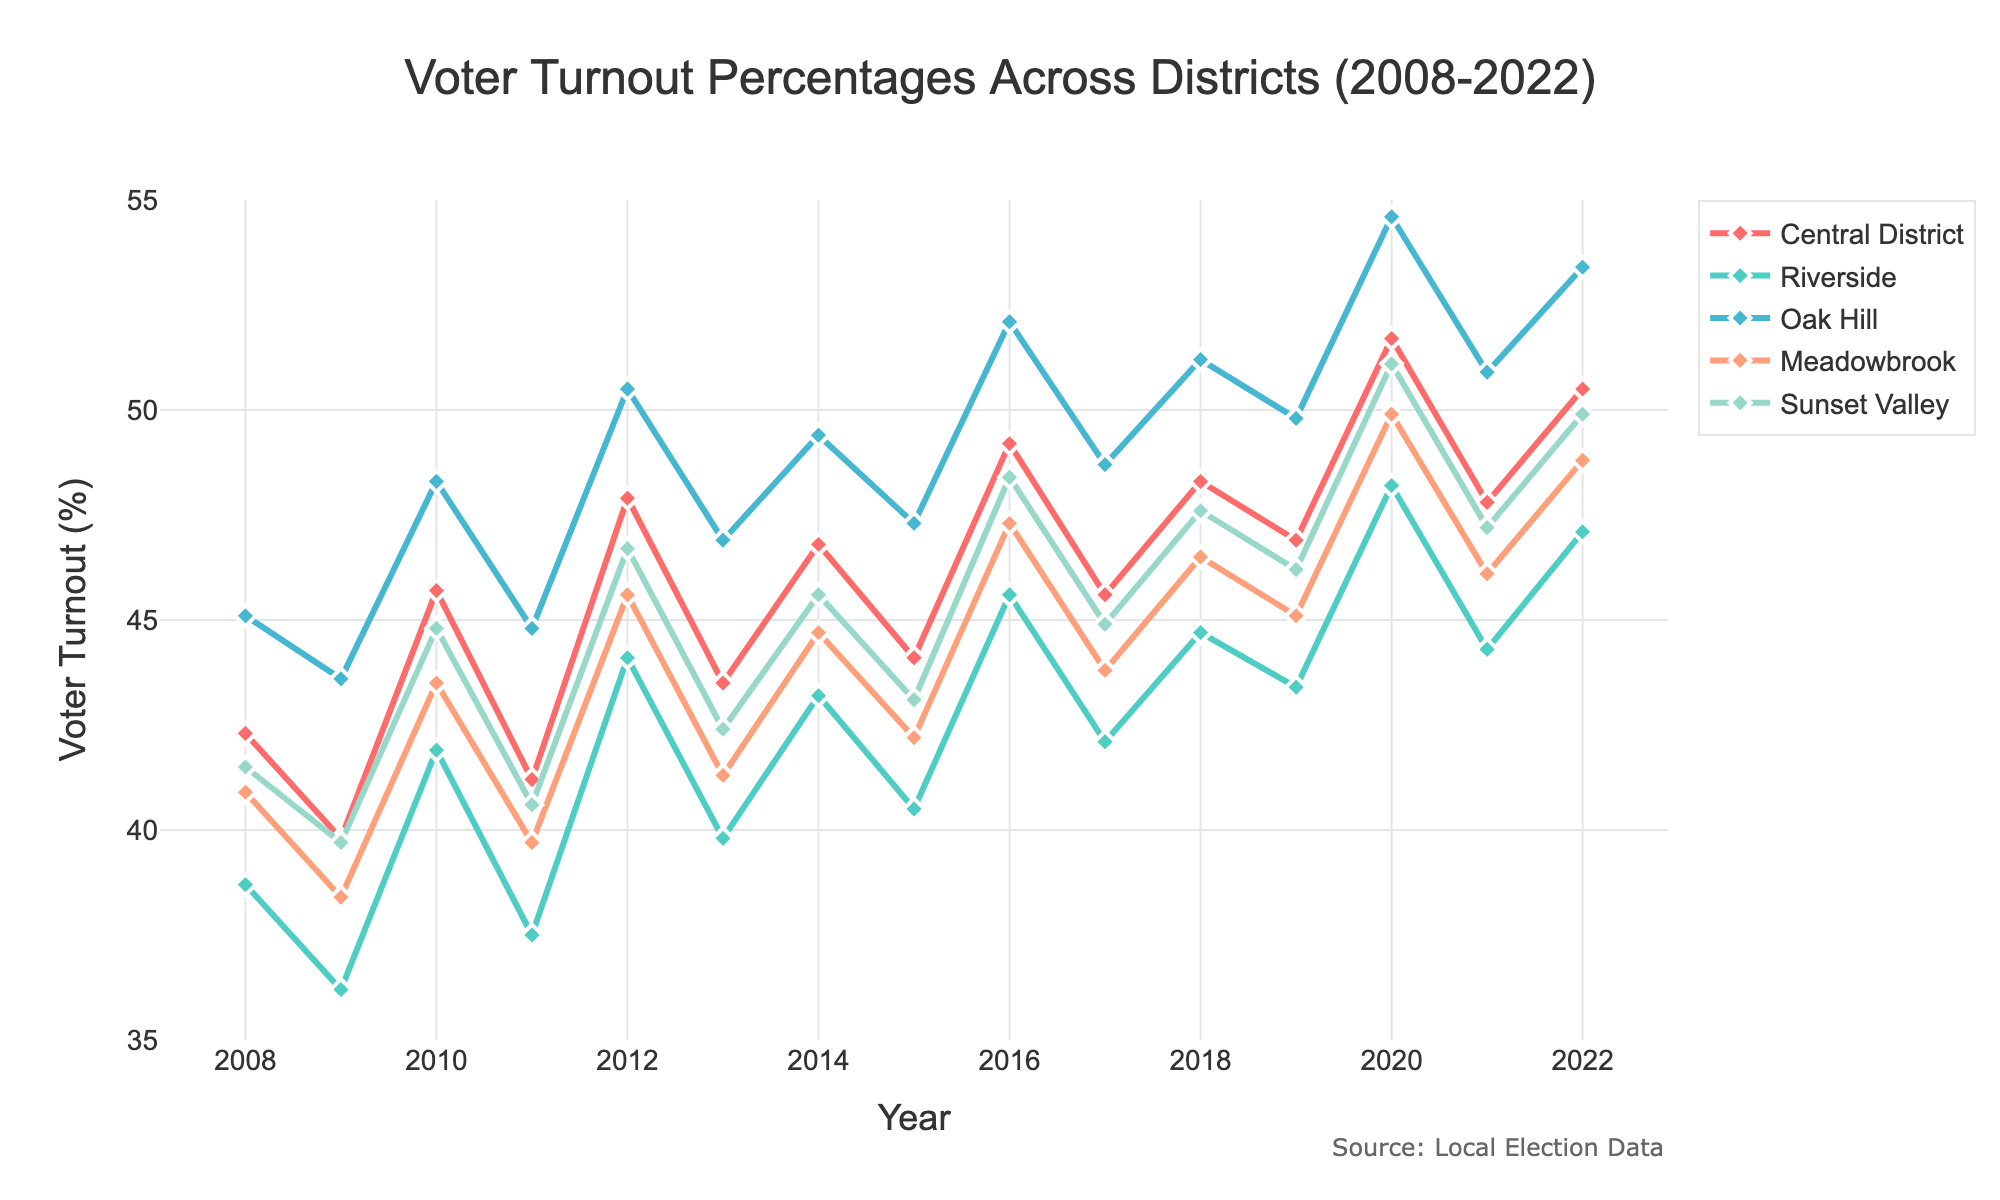What is the general trend of voter turnout in the Central District over the 15 years? The voter turnout in the Central District shows a general increasing trend over the 15 years, starting around 42.3% in 2008 and rising to 50.5% in 2022. This indicates an overall improvement in civic engagement in this district.
Answer: Increasing Which district had the highest voter turnout in 2016? By examining the data for 2016, Oak Hill had the highest voter turnout with 52.1%, compared to the other districts.
Answer: Oak Hill How does the voter turnout in Meadowbrook in 2022 compare to its turnout in 2008? Meadowbrook had a voter turnout of 40.9% in 2008 and improved to 48.8% in 2022. This is an increase of 7.9 percentage points.
Answer: 48.8% in 2022 and 40.9% in 2008 Which district shows the most fluctuation in voter turnout percentages over the years? By comparing the lines visually, Oak Hill shows the most fluctuation in voter turnout percentages with notable increases and decreases at various points.
Answer: Oak Hill In which year did Riverside experience the lowest voter turnout, and what was the percentage? Riverside experienced the lowest voter turnout in 2009, with a turnout percentage of 36.2%.
Answer: 2009, 36.2% What's the average voter turnout in Sunset Valley across the 15 years? To find the average, sum the turnout percentages for Sunset Valley across all years and divide by 15. (41.5 + 39.7 + 44.8 + 40.6 + 46.7 + 42.4 + 45.6 + 43.1 + 48.4 + 44.9 + 47.6 + 46.2 + 51.1 + 47.2 + 49.9) / 15 = 44.9%
Answer: 44.9% Which year had the highest overall voter turnout percentage among all districts? By observing the highest peaks on the graph, the year 2020 had the highest voter turnout percentage overall, with notable peaks across all districts.
Answer: 2020 Compare the voter turnout trend of Riverside to Sunset Valley. Which one had more consistent growth? By looking at the lines, Riverside shows more steady growth than Sunset Valley, which has more variations year by year. Riverside's turnout increased more consistently over time.
Answer: Riverside What is the difference in voter turnout between Oak Hill and Central District in 2020? The voter turnout in 2020 for Oak Hill was 54.6%, and for the Central District, it was 51.7%. The difference is 54.6% - 51.7% = 2.9%.
Answer: 2.9% Which district had the lowest voter turnout in 2008, and what was the percentage? In 2008, Riverside had the lowest voter turnout at 38.7%.
Answer: Riverside, 38.7% 